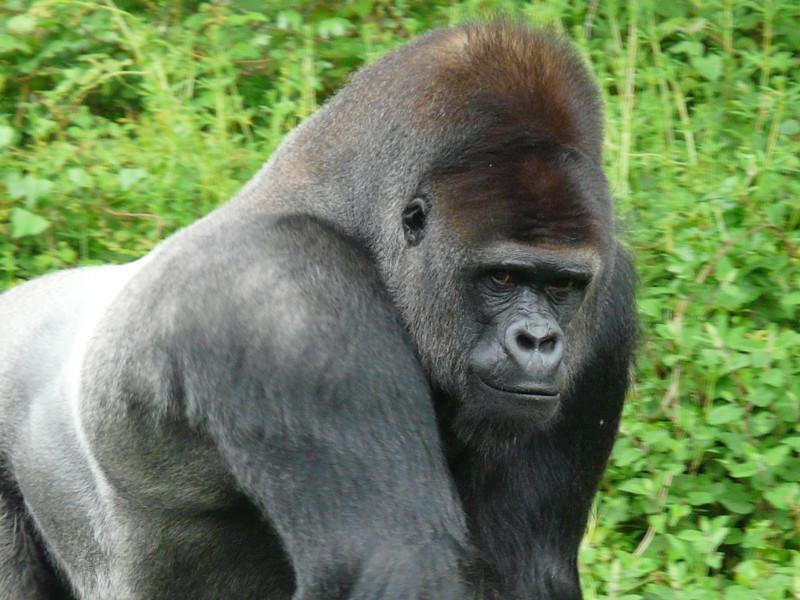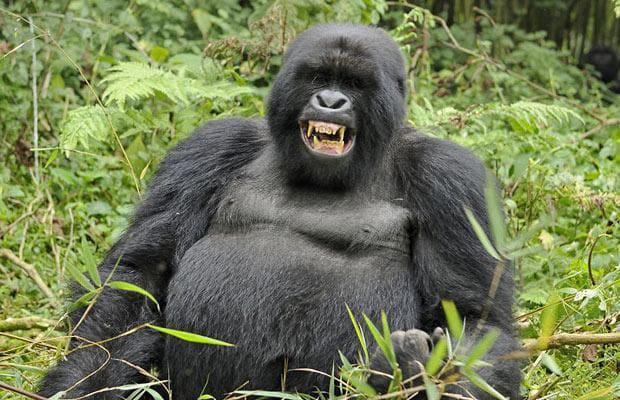The first image is the image on the left, the second image is the image on the right. Evaluate the accuracy of this statement regarding the images: "In the image to the right, a gorilla stands on all fours.". Is it true? Answer yes or no. No. The first image is the image on the left, the second image is the image on the right. Analyze the images presented: Is the assertion "In the right image, there's a silverback gorilla standing on all fours." valid? Answer yes or no. No. 